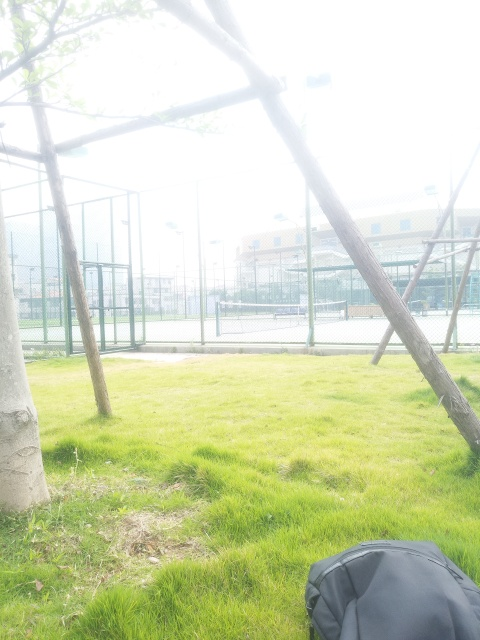Is this image taken during a particular time of day? It seems like the photo was taken during the daytime when the sun is quite strong, potentially around midday, given the brightness and the fact that shadows are not very pronounced. This assumption is based on the amount of light present and the lack of any visible artificial light sources. 